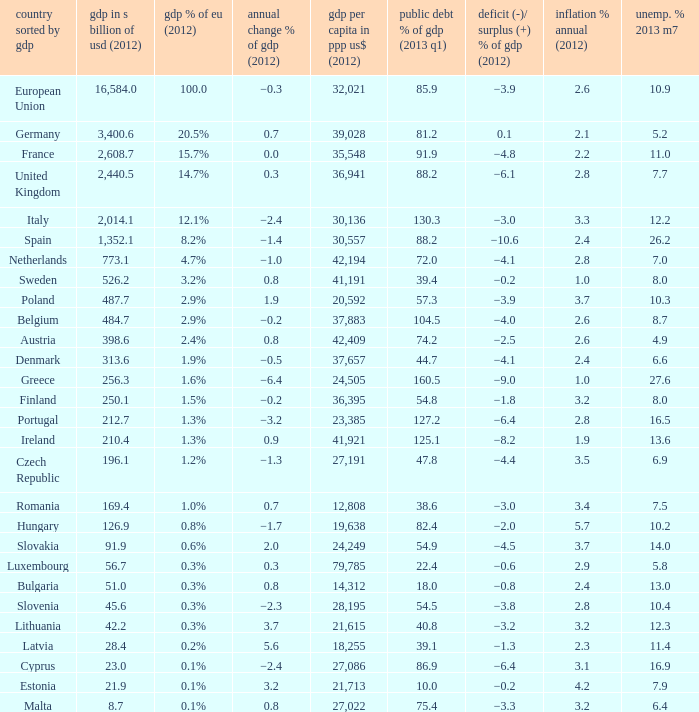What is the GDP % of EU in 2012 of the country with a GDP in billions of USD in 2012 of 256.3? 1.6%. 